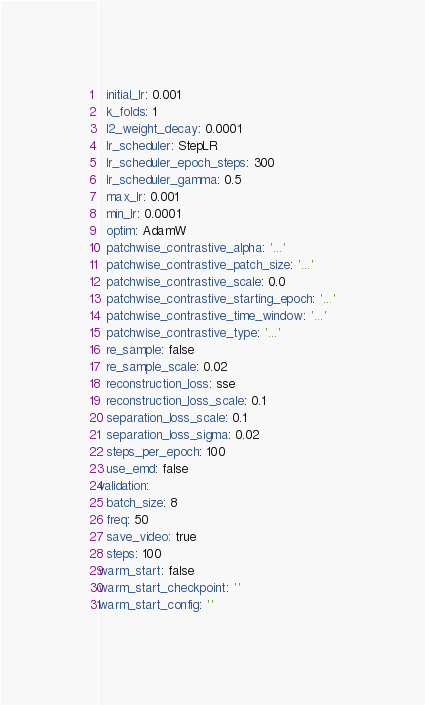<code> <loc_0><loc_0><loc_500><loc_500><_YAML_>  initial_lr: 0.001
  k_folds: 1
  l2_weight_decay: 0.0001
  lr_scheduler: StepLR
  lr_scheduler_epoch_steps: 300
  lr_scheduler_gamma: 0.5
  max_lr: 0.001
  min_lr: 0.0001
  optim: AdamW
  patchwise_contrastive_alpha: '...'
  patchwise_contrastive_patch_size: '...'
  patchwise_contrastive_scale: 0.0
  patchwise_contrastive_starting_epoch: '...'
  patchwise_contrastive_time_window: '...'
  patchwise_contrastive_type: '...'
  re_sample: false
  re_sample_scale: 0.02
  reconstruction_loss: sse
  reconstruction_loss_scale: 0.1
  separation_loss_scale: 0.1
  separation_loss_sigma: 0.02
  steps_per_epoch: 100
  use_emd: false
validation:
  batch_size: 8
  freq: 50
  save_video: true
  steps: 100
warm_start: false
warm_start_checkpoint: ''
warm_start_config: ''
</code> 